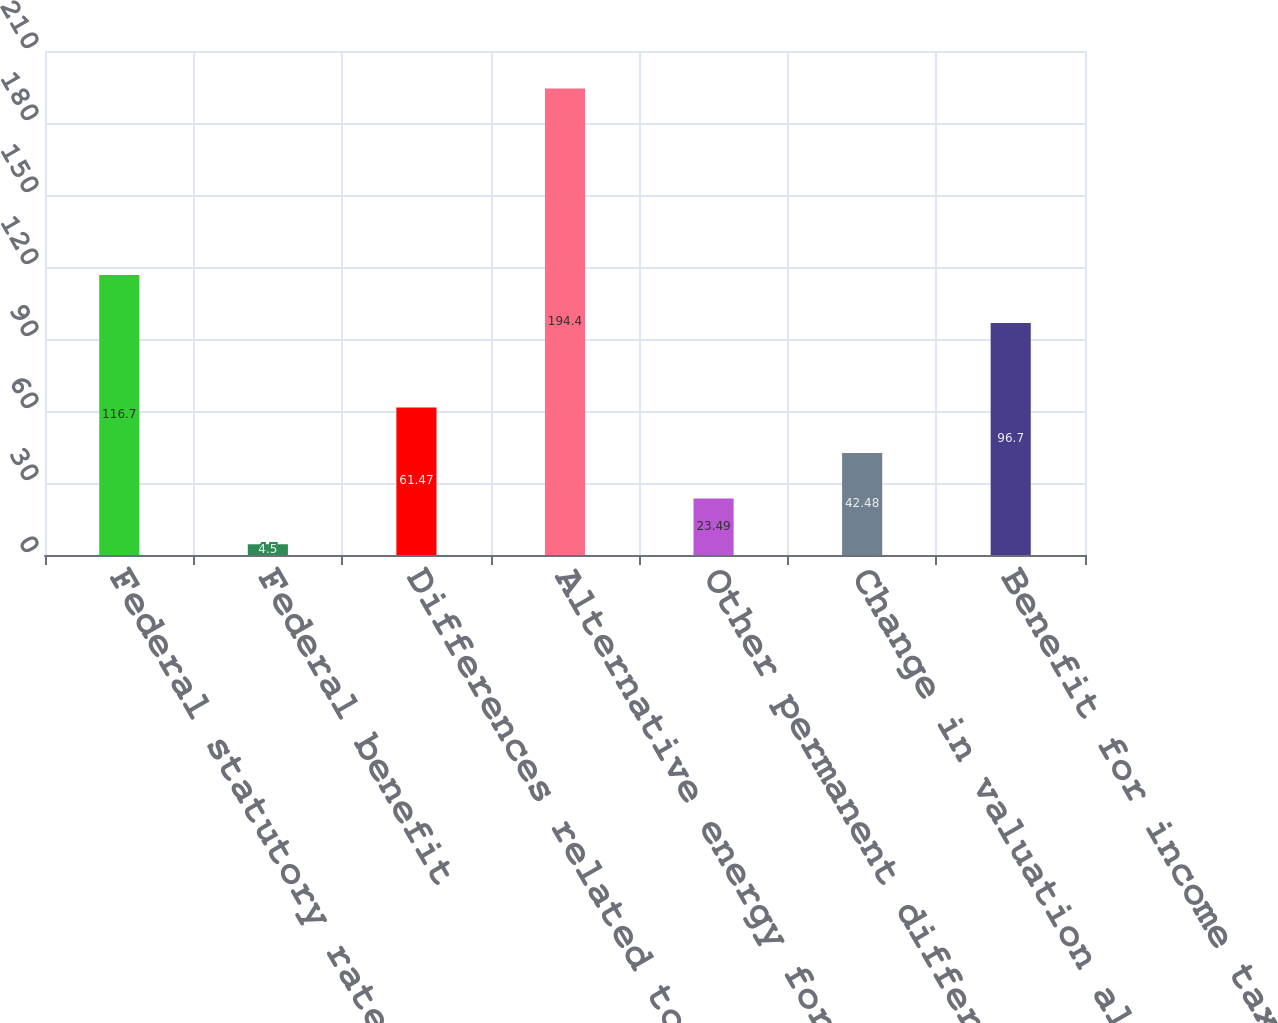Convert chart. <chart><loc_0><loc_0><loc_500><loc_500><bar_chart><fcel>Federal statutory rate<fcel>Federal benefit<fcel>Differences related to non US<fcel>Alternative energy foreign and<fcel>Other permanent differences<fcel>Change in valuation allowance<fcel>Benefit for income taxes<nl><fcel>116.7<fcel>4.5<fcel>61.47<fcel>194.4<fcel>23.49<fcel>42.48<fcel>96.7<nl></chart> 